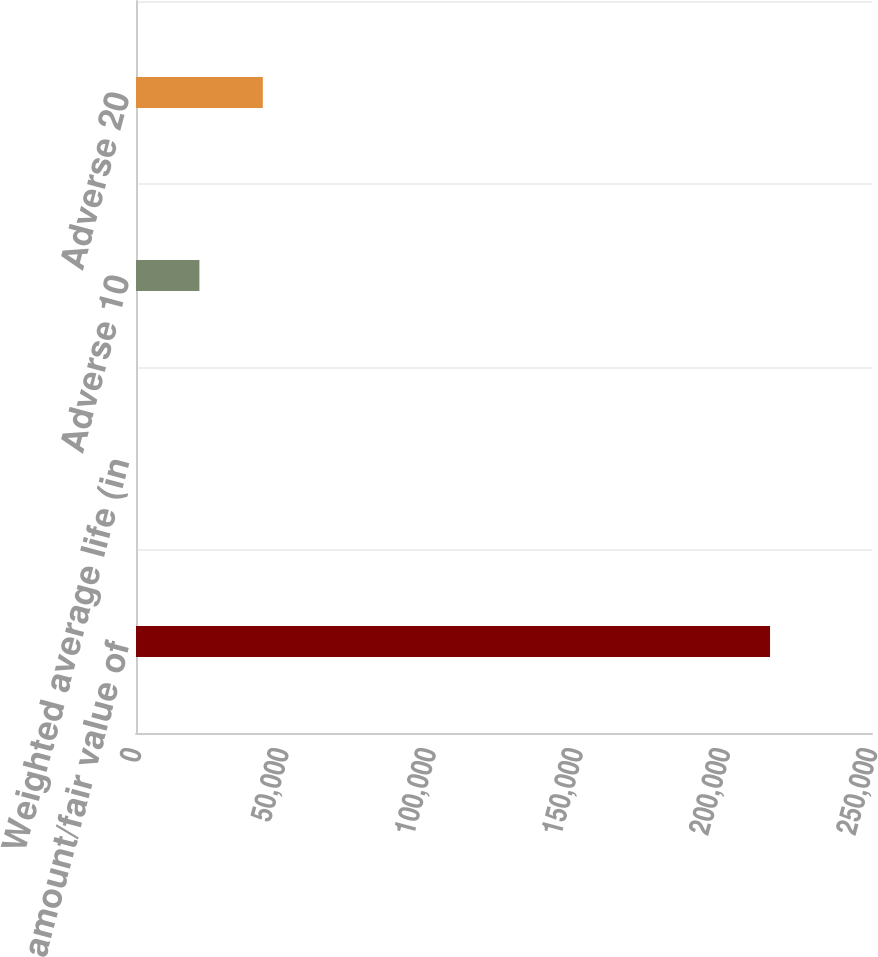<chart> <loc_0><loc_0><loc_500><loc_500><bar_chart><fcel>Carrying amount/fair value of<fcel>Weighted average life (in<fcel>Adverse 10<fcel>Adverse 20<nl><fcel>215367<fcel>2.3<fcel>21538.8<fcel>43075.2<nl></chart> 